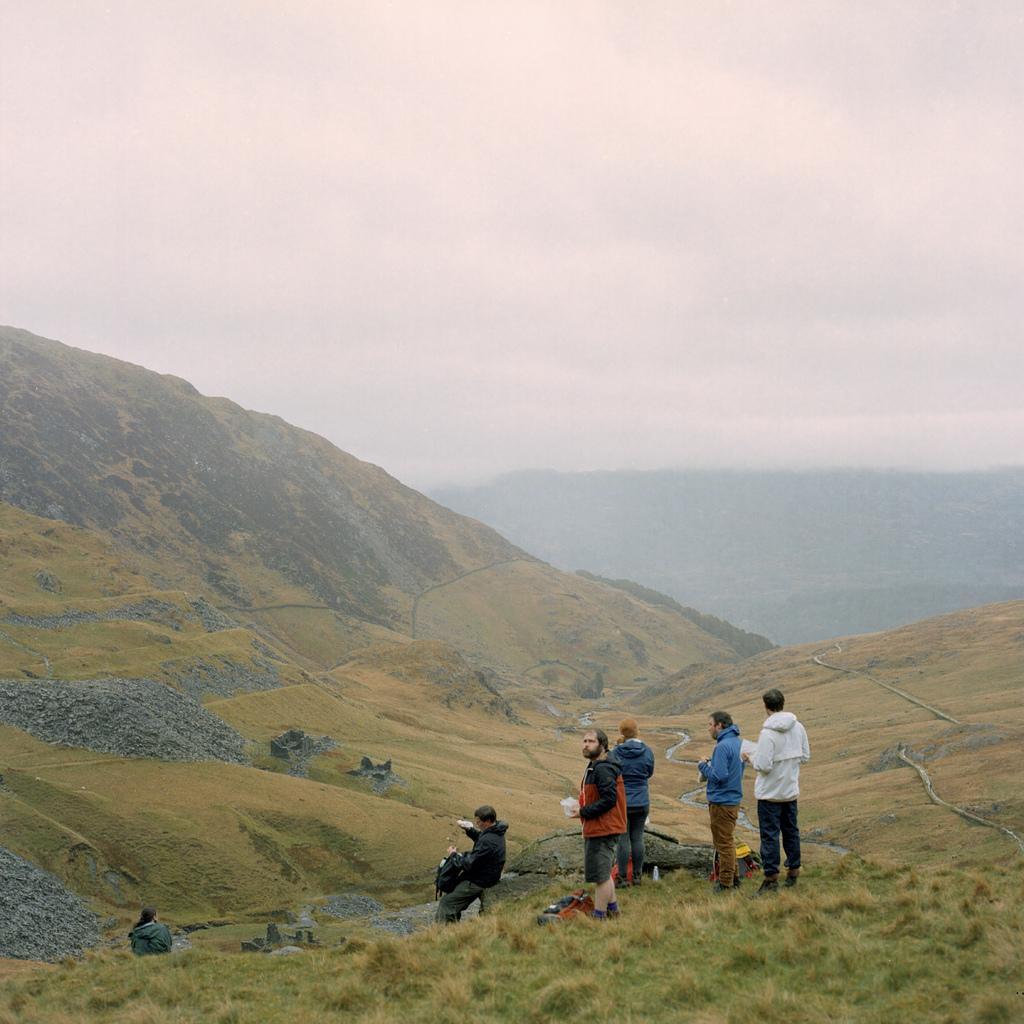Please provide a concise description of this image. In this image there are group of persons standing on the grass , and at the background there are hills,sky. 